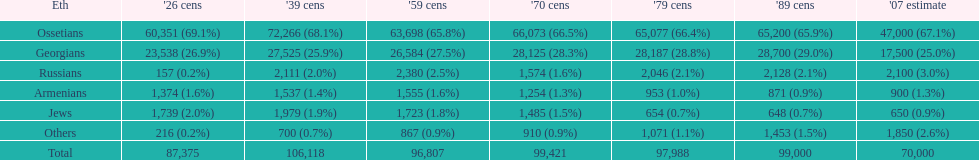Which population had the most people in 1926? Ossetians. 